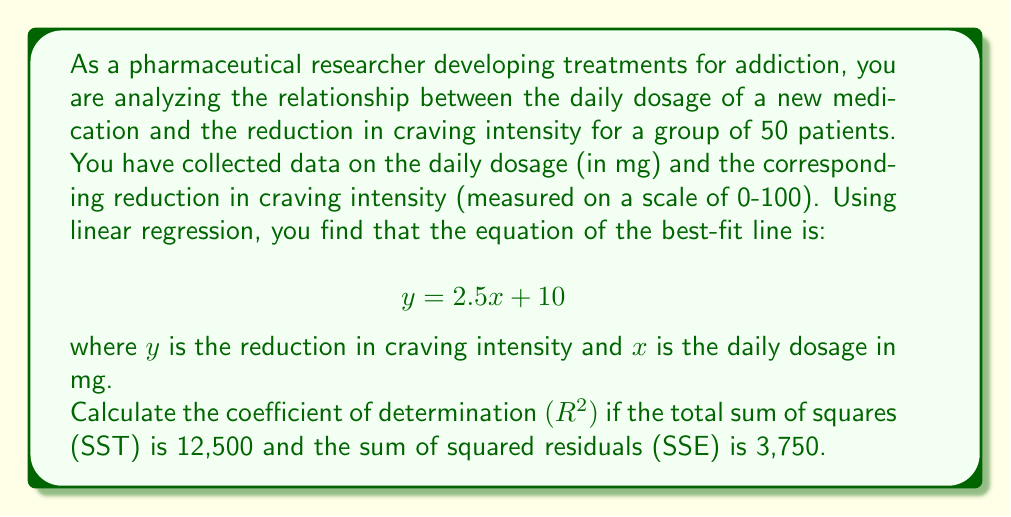Give your solution to this math problem. To solve this problem, we need to understand the concept of the coefficient of determination $(R^2)$ and its relationship to the total sum of squares (SST) and the sum of squared residuals (SSE).

1. The coefficient of determination $(R^2)$ is a measure of how well the regression model fits the data. It represents the proportion of the variance in the dependent variable (reduction in craving intensity) that is predictable from the independent variable (daily dosage).

2. The formula for $R^2$ is:

   $$R^2 = 1 - \frac{SSE}{SST}$$

   where SSE is the sum of squared residuals and SST is the total sum of squares.

3. We are given:
   SST = 12,500
   SSE = 3,750

4. Substituting these values into the formula:

   $$R^2 = 1 - \frac{3,750}{12,500}$$

5. Simplifying:
   $$R^2 = 1 - 0.3$$
   $$R^2 = 0.7$$

6. Therefore, the coefficient of determination is 0.7 or 70%.

This means that 70% of the variability in the reduction of craving intensity can be explained by the daily dosage of the medication. This suggests a moderately strong relationship between the dosage and the reduction in craving intensity.
Answer: $R^2 = 0.7$ or 70% 